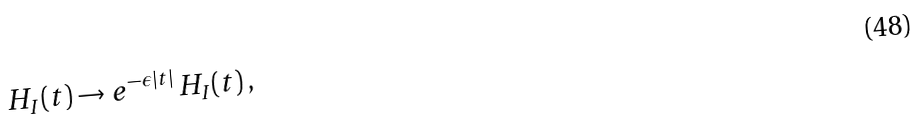Convert formula to latex. <formula><loc_0><loc_0><loc_500><loc_500>H _ { I } ( t ) \rightarrow e ^ { - \epsilon | t | } \, H _ { I } ( t ) \, ,</formula> 